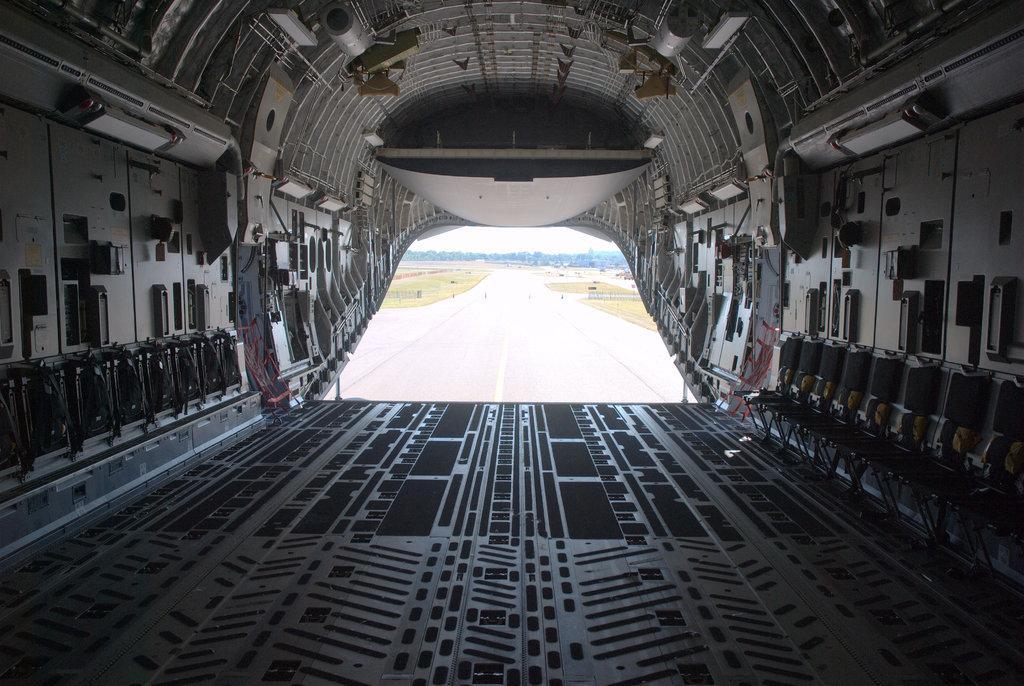Describe this image in one or two sentences. This is an inside view of a vehicle in this image, on the right side there are some chairs and there are some other objects. In the background there is a road, grass, trees and sky. 